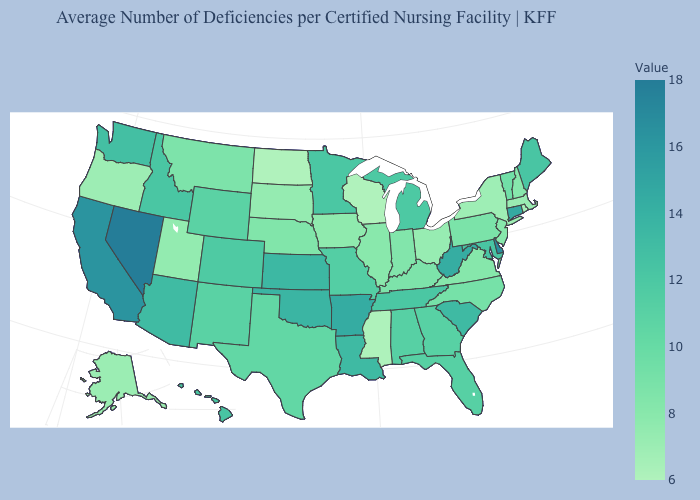Is the legend a continuous bar?
Short answer required. Yes. Does the map have missing data?
Answer briefly. No. Does Alaska have the highest value in the West?
Concise answer only. No. Does Connecticut have the highest value in the Northeast?
Give a very brief answer. Yes. Does the map have missing data?
Be succinct. No. 